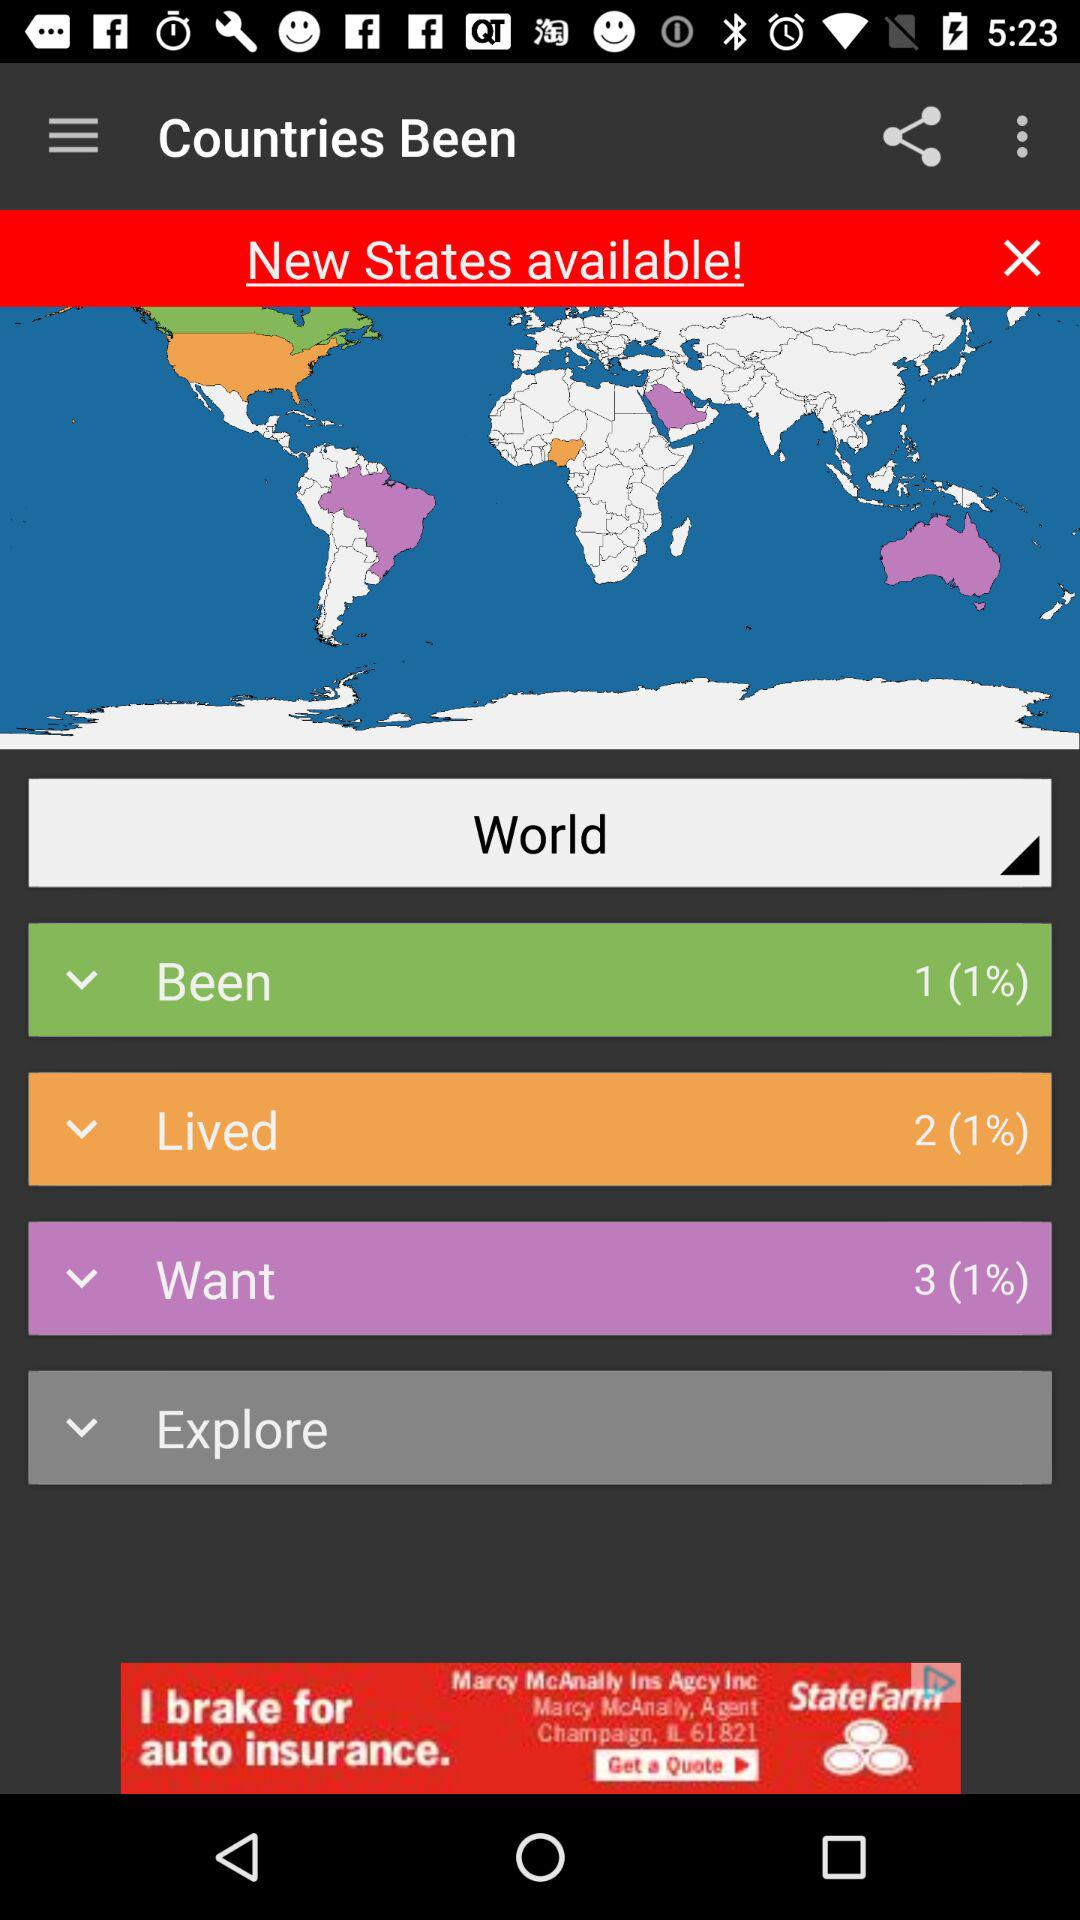What is the total number of countries the user has lived in? The total number of countries the user has lived in is 2. 